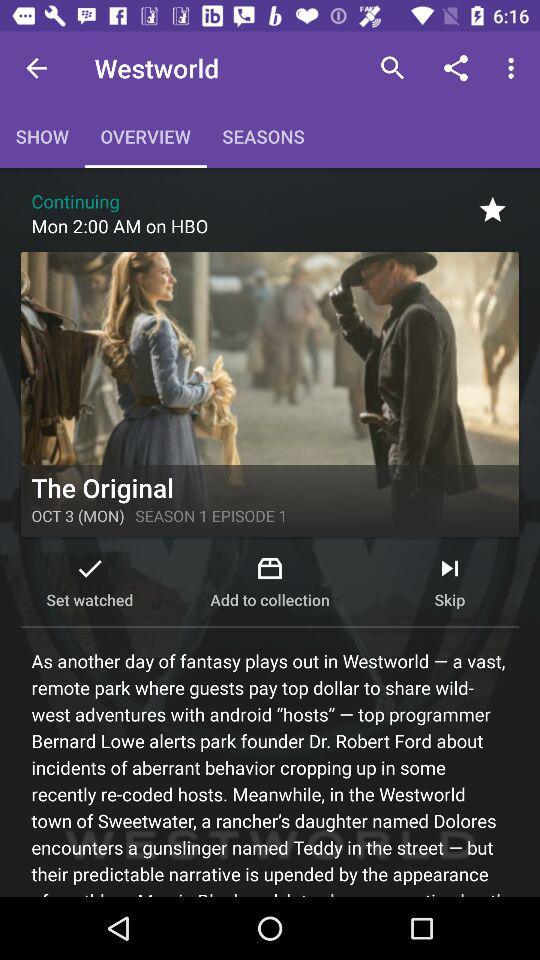What is the timing for continuing the season on HBO? The time is 2:00 AM. 